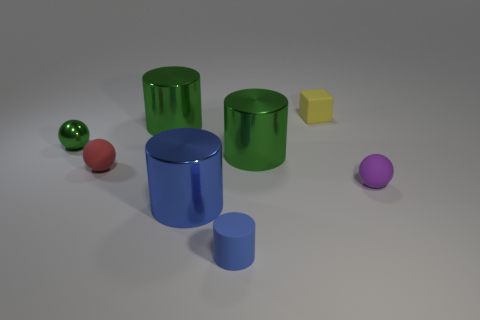What number of other objects are the same color as the small rubber block?
Your answer should be very brief. 0. Is the number of spheres that are in front of the tiny blue matte cylinder less than the number of tiny red matte balls?
Your response must be concise. Yes. Is there a blue matte thing of the same size as the purple ball?
Give a very brief answer. Yes. Is the color of the small matte block the same as the rubber thing left of the big blue thing?
Your answer should be compact. No. What number of yellow matte things are on the left side of the big green cylinder to the left of the matte cylinder?
Your answer should be very brief. 0. What is the color of the shiny cylinder in front of the tiny sphere to the right of the tiny cube?
Keep it short and to the point. Blue. There is a big cylinder that is both behind the big blue object and left of the matte cylinder; what is its material?
Offer a very short reply. Metal. Is there a small green matte thing of the same shape as the small green metal object?
Offer a terse response. No. There is a large metal object that is in front of the red object; is its shape the same as the red object?
Keep it short and to the point. No. How many rubber objects are to the right of the red thing and behind the tiny blue matte cylinder?
Keep it short and to the point. 2. 